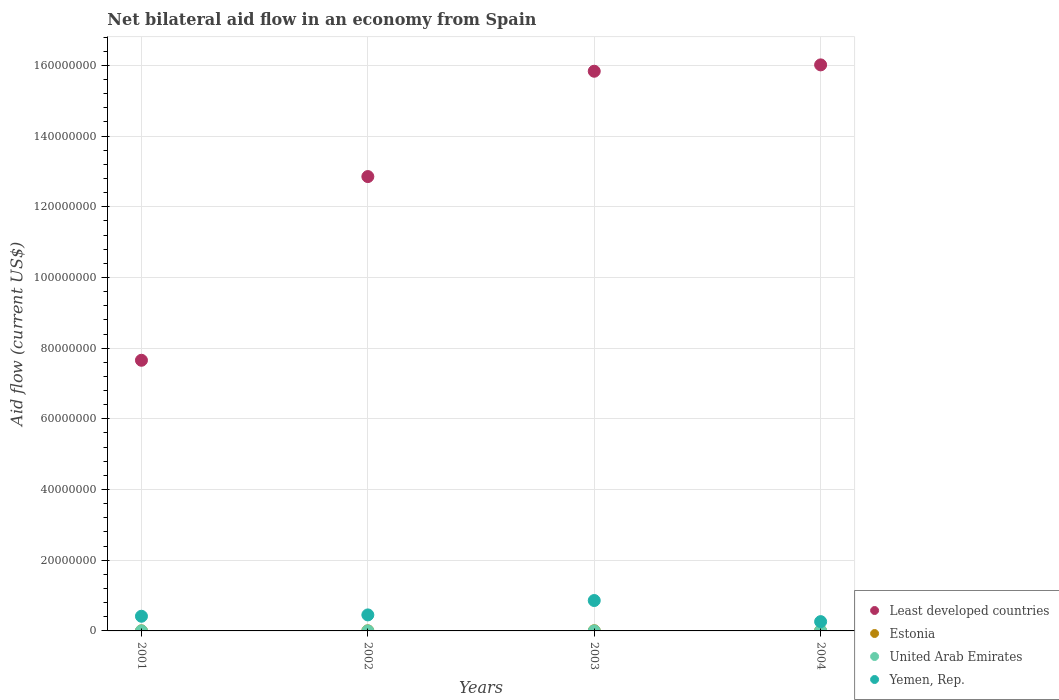How many different coloured dotlines are there?
Ensure brevity in your answer.  4. Is the number of dotlines equal to the number of legend labels?
Keep it short and to the point. Yes. What is the net bilateral aid flow in Least developed countries in 2004?
Provide a short and direct response. 1.60e+08. Across all years, what is the minimum net bilateral aid flow in United Arab Emirates?
Offer a very short reply. 10000. In which year was the net bilateral aid flow in Estonia maximum?
Your answer should be very brief. 2004. What is the total net bilateral aid flow in United Arab Emirates in the graph?
Offer a terse response. 6.00e+04. What is the difference between the net bilateral aid flow in Yemen, Rep. in 2003 and the net bilateral aid flow in Least developed countries in 2001?
Provide a short and direct response. -6.80e+07. What is the average net bilateral aid flow in Yemen, Rep. per year?
Your answer should be compact. 4.98e+06. In the year 2003, what is the difference between the net bilateral aid flow in United Arab Emirates and net bilateral aid flow in Least developed countries?
Ensure brevity in your answer.  -1.58e+08. In how many years, is the net bilateral aid flow in Least developed countries greater than 28000000 US$?
Your answer should be compact. 4. What is the ratio of the net bilateral aid flow in Least developed countries in 2002 to that in 2004?
Your answer should be compact. 0.8. What is the difference between the highest and the second highest net bilateral aid flow in Estonia?
Offer a terse response. 10000. What is the difference between the highest and the lowest net bilateral aid flow in United Arab Emirates?
Your answer should be compact. 2.00e+04. In how many years, is the net bilateral aid flow in Yemen, Rep. greater than the average net bilateral aid flow in Yemen, Rep. taken over all years?
Offer a terse response. 1. Is it the case that in every year, the sum of the net bilateral aid flow in United Arab Emirates and net bilateral aid flow in Least developed countries  is greater than the sum of net bilateral aid flow in Yemen, Rep. and net bilateral aid flow in Estonia?
Your response must be concise. No. Is it the case that in every year, the sum of the net bilateral aid flow in Estonia and net bilateral aid flow in United Arab Emirates  is greater than the net bilateral aid flow in Least developed countries?
Your response must be concise. No. Is the net bilateral aid flow in Yemen, Rep. strictly greater than the net bilateral aid flow in United Arab Emirates over the years?
Your answer should be compact. Yes. What is the difference between two consecutive major ticks on the Y-axis?
Offer a very short reply. 2.00e+07. How many legend labels are there?
Provide a succinct answer. 4. How are the legend labels stacked?
Keep it short and to the point. Vertical. What is the title of the graph?
Provide a succinct answer. Net bilateral aid flow in an economy from Spain. Does "Turkey" appear as one of the legend labels in the graph?
Your response must be concise. No. What is the label or title of the Y-axis?
Offer a very short reply. Aid flow (current US$). What is the Aid flow (current US$) in Least developed countries in 2001?
Keep it short and to the point. 7.66e+07. What is the Aid flow (current US$) in United Arab Emirates in 2001?
Keep it short and to the point. 10000. What is the Aid flow (current US$) in Yemen, Rep. in 2001?
Provide a short and direct response. 4.15e+06. What is the Aid flow (current US$) in Least developed countries in 2002?
Your response must be concise. 1.29e+08. What is the Aid flow (current US$) in Estonia in 2002?
Ensure brevity in your answer.  3.00e+04. What is the Aid flow (current US$) in Yemen, Rep. in 2002?
Ensure brevity in your answer.  4.53e+06. What is the Aid flow (current US$) in Least developed countries in 2003?
Keep it short and to the point. 1.58e+08. What is the Aid flow (current US$) of Estonia in 2003?
Offer a very short reply. 5.00e+04. What is the Aid flow (current US$) in United Arab Emirates in 2003?
Your answer should be compact. 10000. What is the Aid flow (current US$) in Yemen, Rep. in 2003?
Make the answer very short. 8.60e+06. What is the Aid flow (current US$) of Least developed countries in 2004?
Provide a succinct answer. 1.60e+08. What is the Aid flow (current US$) of Estonia in 2004?
Give a very brief answer. 6.00e+04. What is the Aid flow (current US$) in Yemen, Rep. in 2004?
Offer a very short reply. 2.63e+06. Across all years, what is the maximum Aid flow (current US$) in Least developed countries?
Your answer should be compact. 1.60e+08. Across all years, what is the maximum Aid flow (current US$) of Yemen, Rep.?
Provide a short and direct response. 8.60e+06. Across all years, what is the minimum Aid flow (current US$) of Least developed countries?
Give a very brief answer. 7.66e+07. Across all years, what is the minimum Aid flow (current US$) of Estonia?
Offer a terse response. 2.00e+04. Across all years, what is the minimum Aid flow (current US$) of Yemen, Rep.?
Offer a terse response. 2.63e+06. What is the total Aid flow (current US$) in Least developed countries in the graph?
Keep it short and to the point. 5.24e+08. What is the total Aid flow (current US$) of Estonia in the graph?
Offer a very short reply. 1.60e+05. What is the total Aid flow (current US$) of Yemen, Rep. in the graph?
Provide a succinct answer. 1.99e+07. What is the difference between the Aid flow (current US$) in Least developed countries in 2001 and that in 2002?
Offer a very short reply. -5.20e+07. What is the difference between the Aid flow (current US$) of Yemen, Rep. in 2001 and that in 2002?
Keep it short and to the point. -3.80e+05. What is the difference between the Aid flow (current US$) in Least developed countries in 2001 and that in 2003?
Your answer should be very brief. -8.18e+07. What is the difference between the Aid flow (current US$) in Estonia in 2001 and that in 2003?
Your answer should be compact. -3.00e+04. What is the difference between the Aid flow (current US$) in Yemen, Rep. in 2001 and that in 2003?
Offer a terse response. -4.45e+06. What is the difference between the Aid flow (current US$) in Least developed countries in 2001 and that in 2004?
Give a very brief answer. -8.36e+07. What is the difference between the Aid flow (current US$) of Yemen, Rep. in 2001 and that in 2004?
Offer a very short reply. 1.52e+06. What is the difference between the Aid flow (current US$) of Least developed countries in 2002 and that in 2003?
Give a very brief answer. -2.98e+07. What is the difference between the Aid flow (current US$) in Estonia in 2002 and that in 2003?
Give a very brief answer. -2.00e+04. What is the difference between the Aid flow (current US$) of Yemen, Rep. in 2002 and that in 2003?
Your answer should be very brief. -4.07e+06. What is the difference between the Aid flow (current US$) in Least developed countries in 2002 and that in 2004?
Give a very brief answer. -3.16e+07. What is the difference between the Aid flow (current US$) of Estonia in 2002 and that in 2004?
Make the answer very short. -3.00e+04. What is the difference between the Aid flow (current US$) of Yemen, Rep. in 2002 and that in 2004?
Your answer should be compact. 1.90e+06. What is the difference between the Aid flow (current US$) of Least developed countries in 2003 and that in 2004?
Your response must be concise. -1.80e+06. What is the difference between the Aid flow (current US$) of United Arab Emirates in 2003 and that in 2004?
Offer a terse response. -2.00e+04. What is the difference between the Aid flow (current US$) in Yemen, Rep. in 2003 and that in 2004?
Offer a terse response. 5.97e+06. What is the difference between the Aid flow (current US$) of Least developed countries in 2001 and the Aid flow (current US$) of Estonia in 2002?
Provide a succinct answer. 7.65e+07. What is the difference between the Aid flow (current US$) of Least developed countries in 2001 and the Aid flow (current US$) of United Arab Emirates in 2002?
Your answer should be compact. 7.66e+07. What is the difference between the Aid flow (current US$) in Least developed countries in 2001 and the Aid flow (current US$) in Yemen, Rep. in 2002?
Provide a succinct answer. 7.20e+07. What is the difference between the Aid flow (current US$) in Estonia in 2001 and the Aid flow (current US$) in United Arab Emirates in 2002?
Offer a terse response. 10000. What is the difference between the Aid flow (current US$) in Estonia in 2001 and the Aid flow (current US$) in Yemen, Rep. in 2002?
Your answer should be compact. -4.51e+06. What is the difference between the Aid flow (current US$) in United Arab Emirates in 2001 and the Aid flow (current US$) in Yemen, Rep. in 2002?
Ensure brevity in your answer.  -4.52e+06. What is the difference between the Aid flow (current US$) in Least developed countries in 2001 and the Aid flow (current US$) in Estonia in 2003?
Your response must be concise. 7.65e+07. What is the difference between the Aid flow (current US$) of Least developed countries in 2001 and the Aid flow (current US$) of United Arab Emirates in 2003?
Keep it short and to the point. 7.66e+07. What is the difference between the Aid flow (current US$) in Least developed countries in 2001 and the Aid flow (current US$) in Yemen, Rep. in 2003?
Offer a very short reply. 6.80e+07. What is the difference between the Aid flow (current US$) in Estonia in 2001 and the Aid flow (current US$) in Yemen, Rep. in 2003?
Give a very brief answer. -8.58e+06. What is the difference between the Aid flow (current US$) of United Arab Emirates in 2001 and the Aid flow (current US$) of Yemen, Rep. in 2003?
Provide a succinct answer. -8.59e+06. What is the difference between the Aid flow (current US$) in Least developed countries in 2001 and the Aid flow (current US$) in Estonia in 2004?
Your response must be concise. 7.65e+07. What is the difference between the Aid flow (current US$) of Least developed countries in 2001 and the Aid flow (current US$) of United Arab Emirates in 2004?
Ensure brevity in your answer.  7.65e+07. What is the difference between the Aid flow (current US$) of Least developed countries in 2001 and the Aid flow (current US$) of Yemen, Rep. in 2004?
Your answer should be very brief. 7.39e+07. What is the difference between the Aid flow (current US$) of Estonia in 2001 and the Aid flow (current US$) of United Arab Emirates in 2004?
Offer a very short reply. -10000. What is the difference between the Aid flow (current US$) of Estonia in 2001 and the Aid flow (current US$) of Yemen, Rep. in 2004?
Your response must be concise. -2.61e+06. What is the difference between the Aid flow (current US$) of United Arab Emirates in 2001 and the Aid flow (current US$) of Yemen, Rep. in 2004?
Provide a succinct answer. -2.62e+06. What is the difference between the Aid flow (current US$) of Least developed countries in 2002 and the Aid flow (current US$) of Estonia in 2003?
Offer a terse response. 1.28e+08. What is the difference between the Aid flow (current US$) of Least developed countries in 2002 and the Aid flow (current US$) of United Arab Emirates in 2003?
Keep it short and to the point. 1.29e+08. What is the difference between the Aid flow (current US$) in Least developed countries in 2002 and the Aid flow (current US$) in Yemen, Rep. in 2003?
Provide a short and direct response. 1.20e+08. What is the difference between the Aid flow (current US$) in Estonia in 2002 and the Aid flow (current US$) in United Arab Emirates in 2003?
Make the answer very short. 2.00e+04. What is the difference between the Aid flow (current US$) of Estonia in 2002 and the Aid flow (current US$) of Yemen, Rep. in 2003?
Provide a short and direct response. -8.57e+06. What is the difference between the Aid flow (current US$) in United Arab Emirates in 2002 and the Aid flow (current US$) in Yemen, Rep. in 2003?
Your answer should be very brief. -8.59e+06. What is the difference between the Aid flow (current US$) of Least developed countries in 2002 and the Aid flow (current US$) of Estonia in 2004?
Keep it short and to the point. 1.28e+08. What is the difference between the Aid flow (current US$) of Least developed countries in 2002 and the Aid flow (current US$) of United Arab Emirates in 2004?
Provide a short and direct response. 1.29e+08. What is the difference between the Aid flow (current US$) of Least developed countries in 2002 and the Aid flow (current US$) of Yemen, Rep. in 2004?
Your answer should be very brief. 1.26e+08. What is the difference between the Aid flow (current US$) of Estonia in 2002 and the Aid flow (current US$) of United Arab Emirates in 2004?
Your answer should be compact. 0. What is the difference between the Aid flow (current US$) of Estonia in 2002 and the Aid flow (current US$) of Yemen, Rep. in 2004?
Provide a short and direct response. -2.60e+06. What is the difference between the Aid flow (current US$) in United Arab Emirates in 2002 and the Aid flow (current US$) in Yemen, Rep. in 2004?
Offer a terse response. -2.62e+06. What is the difference between the Aid flow (current US$) of Least developed countries in 2003 and the Aid flow (current US$) of Estonia in 2004?
Give a very brief answer. 1.58e+08. What is the difference between the Aid flow (current US$) of Least developed countries in 2003 and the Aid flow (current US$) of United Arab Emirates in 2004?
Give a very brief answer. 1.58e+08. What is the difference between the Aid flow (current US$) of Least developed countries in 2003 and the Aid flow (current US$) of Yemen, Rep. in 2004?
Provide a succinct answer. 1.56e+08. What is the difference between the Aid flow (current US$) in Estonia in 2003 and the Aid flow (current US$) in Yemen, Rep. in 2004?
Your answer should be compact. -2.58e+06. What is the difference between the Aid flow (current US$) of United Arab Emirates in 2003 and the Aid flow (current US$) of Yemen, Rep. in 2004?
Your answer should be compact. -2.62e+06. What is the average Aid flow (current US$) of Least developed countries per year?
Your response must be concise. 1.31e+08. What is the average Aid flow (current US$) of United Arab Emirates per year?
Your answer should be compact. 1.50e+04. What is the average Aid flow (current US$) of Yemen, Rep. per year?
Ensure brevity in your answer.  4.98e+06. In the year 2001, what is the difference between the Aid flow (current US$) of Least developed countries and Aid flow (current US$) of Estonia?
Offer a terse response. 7.66e+07. In the year 2001, what is the difference between the Aid flow (current US$) in Least developed countries and Aid flow (current US$) in United Arab Emirates?
Provide a succinct answer. 7.66e+07. In the year 2001, what is the difference between the Aid flow (current US$) of Least developed countries and Aid flow (current US$) of Yemen, Rep.?
Your answer should be very brief. 7.24e+07. In the year 2001, what is the difference between the Aid flow (current US$) in Estonia and Aid flow (current US$) in United Arab Emirates?
Your answer should be compact. 10000. In the year 2001, what is the difference between the Aid flow (current US$) of Estonia and Aid flow (current US$) of Yemen, Rep.?
Your answer should be compact. -4.13e+06. In the year 2001, what is the difference between the Aid flow (current US$) in United Arab Emirates and Aid flow (current US$) in Yemen, Rep.?
Ensure brevity in your answer.  -4.14e+06. In the year 2002, what is the difference between the Aid flow (current US$) of Least developed countries and Aid flow (current US$) of Estonia?
Offer a very short reply. 1.29e+08. In the year 2002, what is the difference between the Aid flow (current US$) of Least developed countries and Aid flow (current US$) of United Arab Emirates?
Your answer should be very brief. 1.29e+08. In the year 2002, what is the difference between the Aid flow (current US$) of Least developed countries and Aid flow (current US$) of Yemen, Rep.?
Give a very brief answer. 1.24e+08. In the year 2002, what is the difference between the Aid flow (current US$) in Estonia and Aid flow (current US$) in United Arab Emirates?
Provide a short and direct response. 2.00e+04. In the year 2002, what is the difference between the Aid flow (current US$) in Estonia and Aid flow (current US$) in Yemen, Rep.?
Keep it short and to the point. -4.50e+06. In the year 2002, what is the difference between the Aid flow (current US$) in United Arab Emirates and Aid flow (current US$) in Yemen, Rep.?
Your answer should be compact. -4.52e+06. In the year 2003, what is the difference between the Aid flow (current US$) in Least developed countries and Aid flow (current US$) in Estonia?
Offer a terse response. 1.58e+08. In the year 2003, what is the difference between the Aid flow (current US$) of Least developed countries and Aid flow (current US$) of United Arab Emirates?
Your answer should be very brief. 1.58e+08. In the year 2003, what is the difference between the Aid flow (current US$) in Least developed countries and Aid flow (current US$) in Yemen, Rep.?
Provide a short and direct response. 1.50e+08. In the year 2003, what is the difference between the Aid flow (current US$) in Estonia and Aid flow (current US$) in Yemen, Rep.?
Ensure brevity in your answer.  -8.55e+06. In the year 2003, what is the difference between the Aid flow (current US$) of United Arab Emirates and Aid flow (current US$) of Yemen, Rep.?
Your response must be concise. -8.59e+06. In the year 2004, what is the difference between the Aid flow (current US$) in Least developed countries and Aid flow (current US$) in Estonia?
Give a very brief answer. 1.60e+08. In the year 2004, what is the difference between the Aid flow (current US$) of Least developed countries and Aid flow (current US$) of United Arab Emirates?
Ensure brevity in your answer.  1.60e+08. In the year 2004, what is the difference between the Aid flow (current US$) of Least developed countries and Aid flow (current US$) of Yemen, Rep.?
Give a very brief answer. 1.58e+08. In the year 2004, what is the difference between the Aid flow (current US$) in Estonia and Aid flow (current US$) in Yemen, Rep.?
Provide a succinct answer. -2.57e+06. In the year 2004, what is the difference between the Aid flow (current US$) in United Arab Emirates and Aid flow (current US$) in Yemen, Rep.?
Provide a succinct answer. -2.60e+06. What is the ratio of the Aid flow (current US$) of Least developed countries in 2001 to that in 2002?
Keep it short and to the point. 0.6. What is the ratio of the Aid flow (current US$) in Estonia in 2001 to that in 2002?
Provide a succinct answer. 0.67. What is the ratio of the Aid flow (current US$) in United Arab Emirates in 2001 to that in 2002?
Offer a very short reply. 1. What is the ratio of the Aid flow (current US$) of Yemen, Rep. in 2001 to that in 2002?
Offer a terse response. 0.92. What is the ratio of the Aid flow (current US$) in Least developed countries in 2001 to that in 2003?
Offer a very short reply. 0.48. What is the ratio of the Aid flow (current US$) in Estonia in 2001 to that in 2003?
Keep it short and to the point. 0.4. What is the ratio of the Aid flow (current US$) of United Arab Emirates in 2001 to that in 2003?
Your answer should be very brief. 1. What is the ratio of the Aid flow (current US$) of Yemen, Rep. in 2001 to that in 2003?
Provide a succinct answer. 0.48. What is the ratio of the Aid flow (current US$) in Least developed countries in 2001 to that in 2004?
Give a very brief answer. 0.48. What is the ratio of the Aid flow (current US$) in United Arab Emirates in 2001 to that in 2004?
Keep it short and to the point. 0.33. What is the ratio of the Aid flow (current US$) in Yemen, Rep. in 2001 to that in 2004?
Ensure brevity in your answer.  1.58. What is the ratio of the Aid flow (current US$) of Least developed countries in 2002 to that in 2003?
Ensure brevity in your answer.  0.81. What is the ratio of the Aid flow (current US$) in Estonia in 2002 to that in 2003?
Your response must be concise. 0.6. What is the ratio of the Aid flow (current US$) in Yemen, Rep. in 2002 to that in 2003?
Your answer should be very brief. 0.53. What is the ratio of the Aid flow (current US$) in Least developed countries in 2002 to that in 2004?
Your answer should be very brief. 0.8. What is the ratio of the Aid flow (current US$) in Estonia in 2002 to that in 2004?
Your answer should be very brief. 0.5. What is the ratio of the Aid flow (current US$) in Yemen, Rep. in 2002 to that in 2004?
Ensure brevity in your answer.  1.72. What is the ratio of the Aid flow (current US$) in Yemen, Rep. in 2003 to that in 2004?
Keep it short and to the point. 3.27. What is the difference between the highest and the second highest Aid flow (current US$) of Least developed countries?
Ensure brevity in your answer.  1.80e+06. What is the difference between the highest and the second highest Aid flow (current US$) in Yemen, Rep.?
Make the answer very short. 4.07e+06. What is the difference between the highest and the lowest Aid flow (current US$) of Least developed countries?
Offer a terse response. 8.36e+07. What is the difference between the highest and the lowest Aid flow (current US$) of Estonia?
Your answer should be compact. 4.00e+04. What is the difference between the highest and the lowest Aid flow (current US$) in United Arab Emirates?
Your response must be concise. 2.00e+04. What is the difference between the highest and the lowest Aid flow (current US$) in Yemen, Rep.?
Your response must be concise. 5.97e+06. 